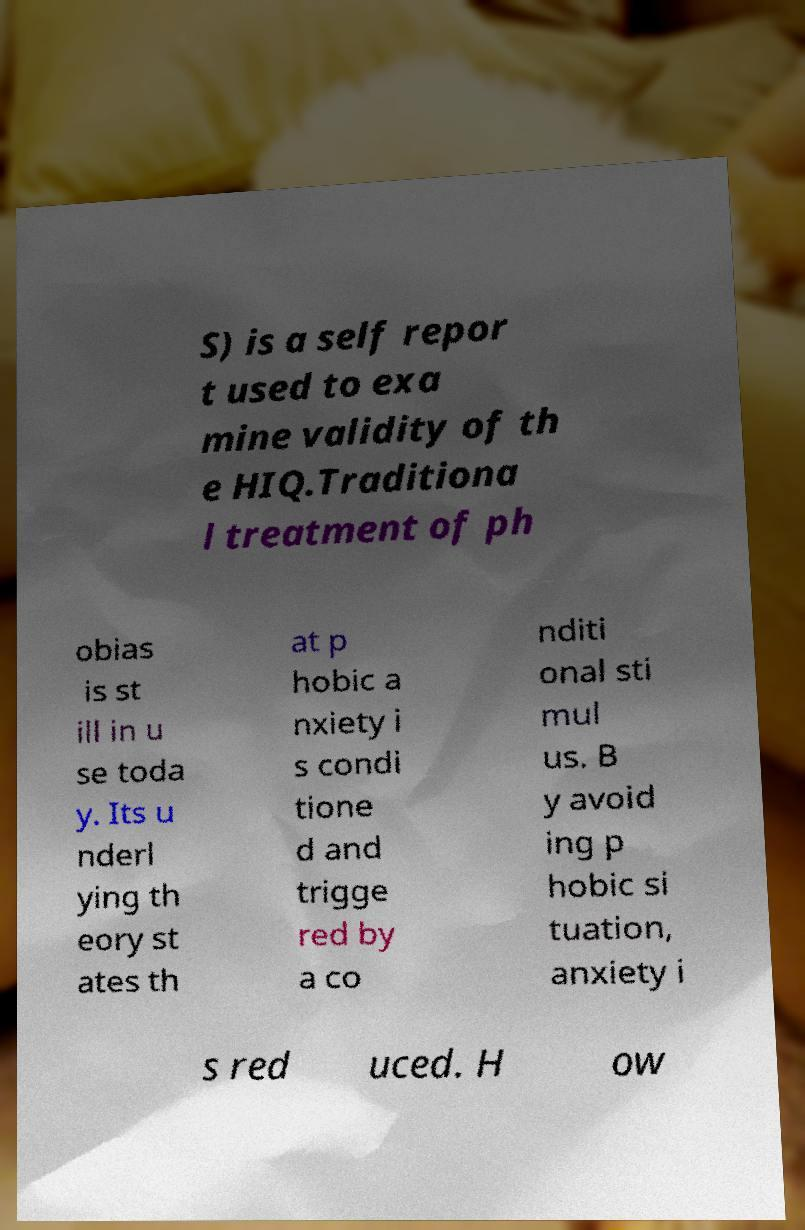Please read and relay the text visible in this image. What does it say? S) is a self repor t used to exa mine validity of th e HIQ.Traditiona l treatment of ph obias is st ill in u se toda y. Its u nderl ying th eory st ates th at p hobic a nxiety i s condi tione d and trigge red by a co nditi onal sti mul us. B y avoid ing p hobic si tuation, anxiety i s red uced. H ow 